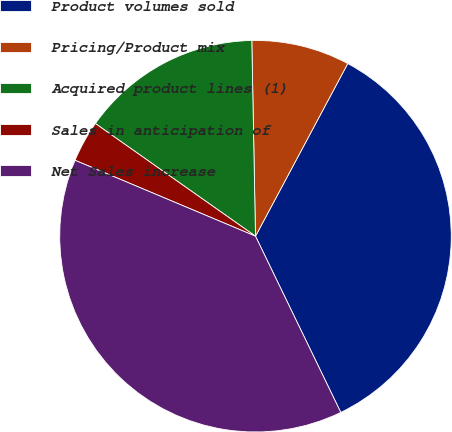<chart> <loc_0><loc_0><loc_500><loc_500><pie_chart><fcel>Product volumes sold<fcel>Pricing/Product mix<fcel>Acquired product lines (1)<fcel>Sales in anticipation of<fcel>Net Sales increase<nl><fcel>35.01%<fcel>8.11%<fcel>14.94%<fcel>3.42%<fcel>38.51%<nl></chart> 